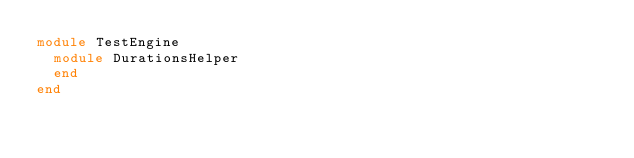<code> <loc_0><loc_0><loc_500><loc_500><_Ruby_>module TestEngine
  module DurationsHelper
  end
end
</code> 